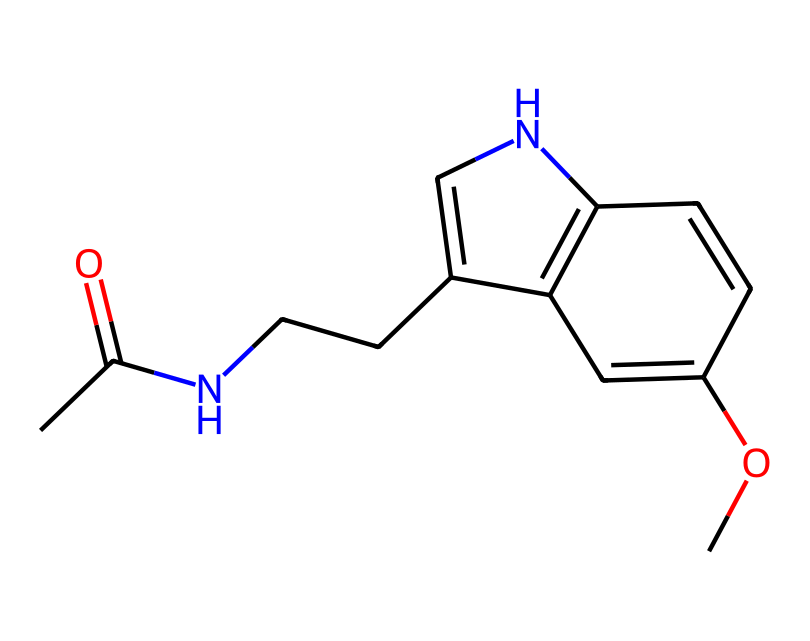What is the molecular formula of melatonin based on the SMILES? By analyzing the provided SMILES, we can count the number of each type of atom present. The SMILES shows carbon (C), hydrogen (H), nitrogen (N), and oxygen (O) atoms. Upon counting, we find that there are 13 carbons, 16 hydrogens, 2 nitrogens, and 1 oxygen, leading to the formula C13H16N2O.
Answer: C13H16N2O How many rings are present in the structure? The SMILES notation indicates cyclic structures through the use of numbers. By identifying the connections in the SMILES, we see two instances of numbered rings (1 and 2), indicating 2 rings.
Answer: 2 What type of chemical bonding is predominantly present in melatonin? The structure contains carbon-carbon, carbon-nitrogen, and carbon-oxygen bonds. The presence of C=O (a carbonyl group) and N-H bonds also indicates strong covalent bonding throughout, which is predominantly single and double bonds.
Answer: covalent What functional groups are present in melatonin? Examining the structure reveals the presence of an amine group (NH) and an ether group (C-O-C). These are important for its biological activity as a sleep regulator.
Answer: amine and ether Which atom in the structure suggests that it can act as a sleep aid? The presence of the nitrogen atoms in the structure is a key factor as they are involved in neurotransmission and binding at specific receptors in the brain, leading to melatonin's activity as a sleep aid.
Answer: nitrogen Is there an atom in melatonin that suggests a role in antioxidant activity? The presence of the oxygen atom indicates potential sites for radical scavenging, as oxygen is a common element involved in metabolic processes related to antioxidant activity.
Answer: oxygen 